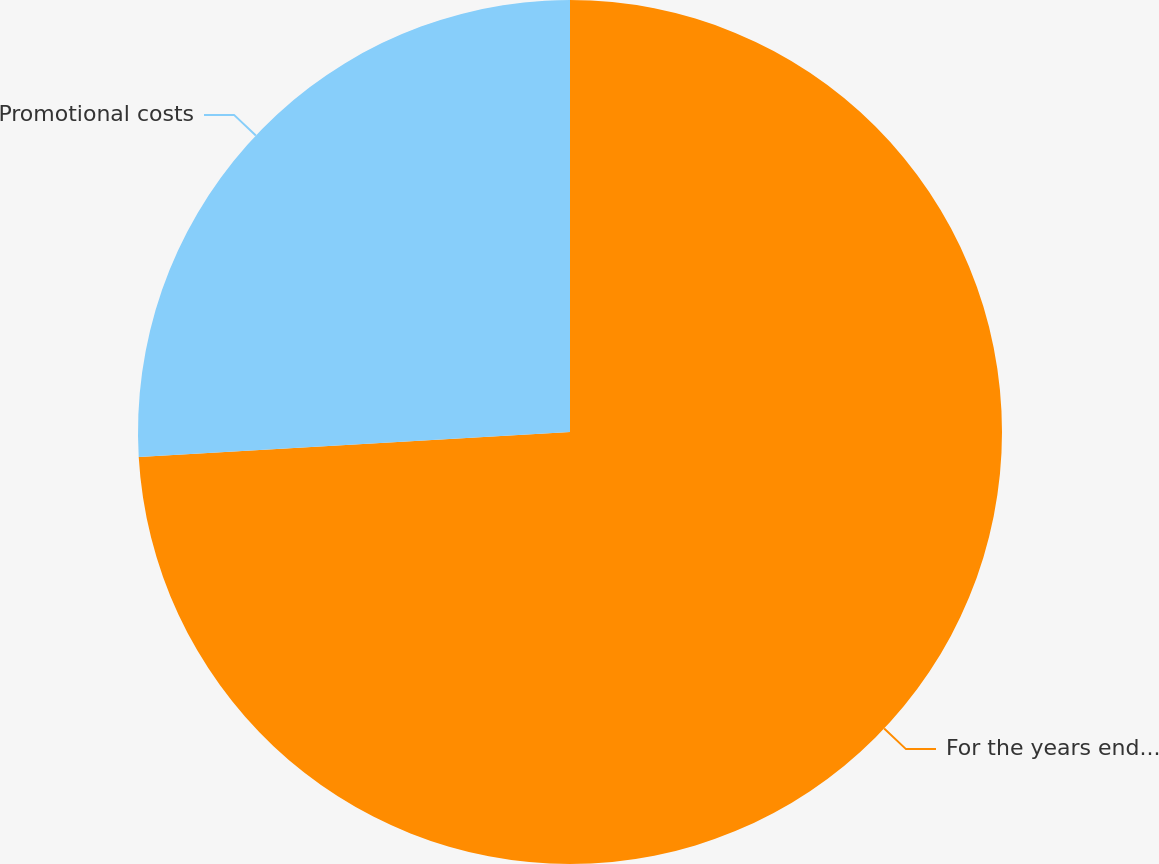Convert chart to OTSL. <chart><loc_0><loc_0><loc_500><loc_500><pie_chart><fcel>For the years ended December<fcel>Promotional costs<nl><fcel>74.08%<fcel>25.92%<nl></chart> 